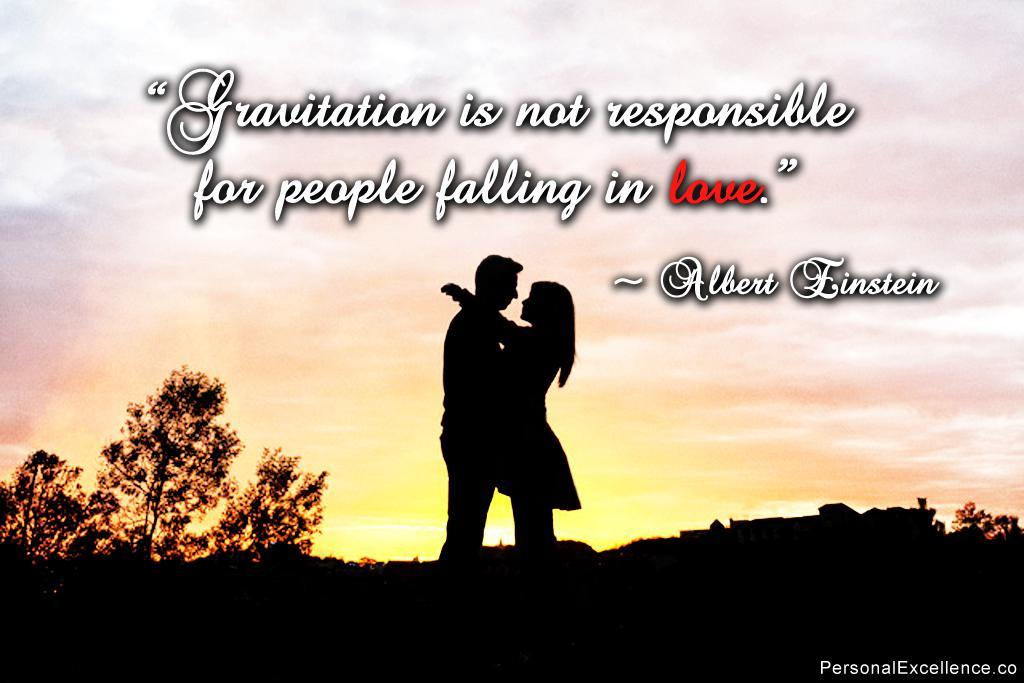How many people are in the image? There are two people standing in the center of the image. What is located on the left side of the image? There are trees on the left side of the image. What is located on the right side of the image? There is a tree on the right side of the image. What can be seen at the top of the image? There is text at the top of the image. What is the condition of the sky in the image? The sky is cloudy in the image. Can you tell me how many eggs are on the lamp in the image? There is no lamp or eggs present in the image. 